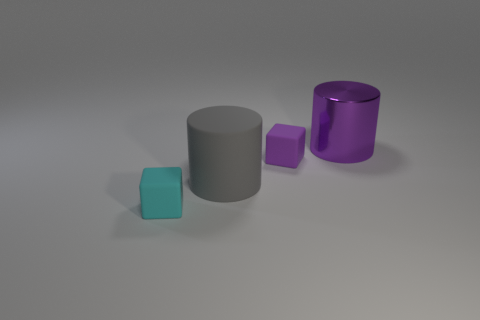Add 4 large gray matte cylinders. How many objects exist? 8 Subtract all gray cylinders. How many cylinders are left? 1 Subtract all green cylinders. Subtract all brown blocks. How many cylinders are left? 2 Subtract all small purple things. Subtract all big cyan objects. How many objects are left? 3 Add 1 large metallic objects. How many large metallic objects are left? 2 Add 4 small metal cubes. How many small metal cubes exist? 4 Subtract 1 purple cylinders. How many objects are left? 3 